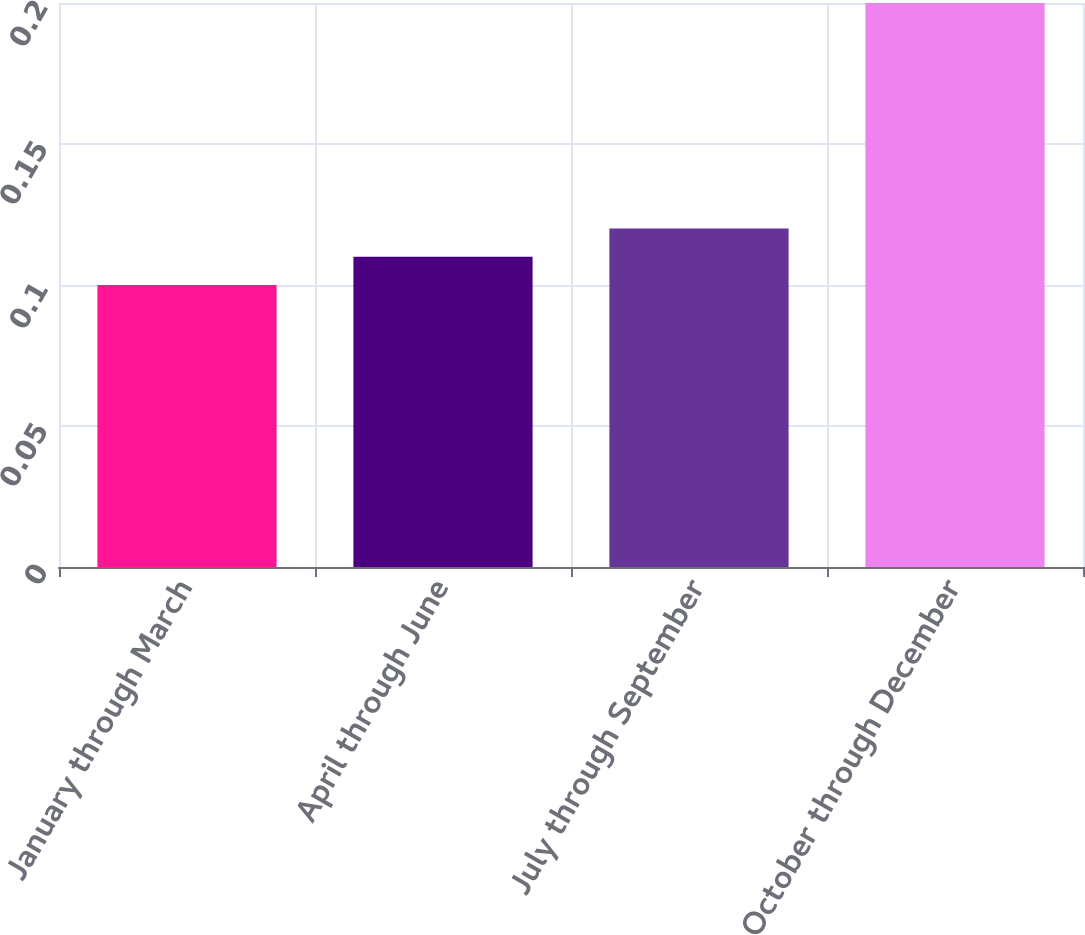Convert chart. <chart><loc_0><loc_0><loc_500><loc_500><bar_chart><fcel>January through March<fcel>April through June<fcel>July through September<fcel>October through December<nl><fcel>0.1<fcel>0.11<fcel>0.12<fcel>0.2<nl></chart> 